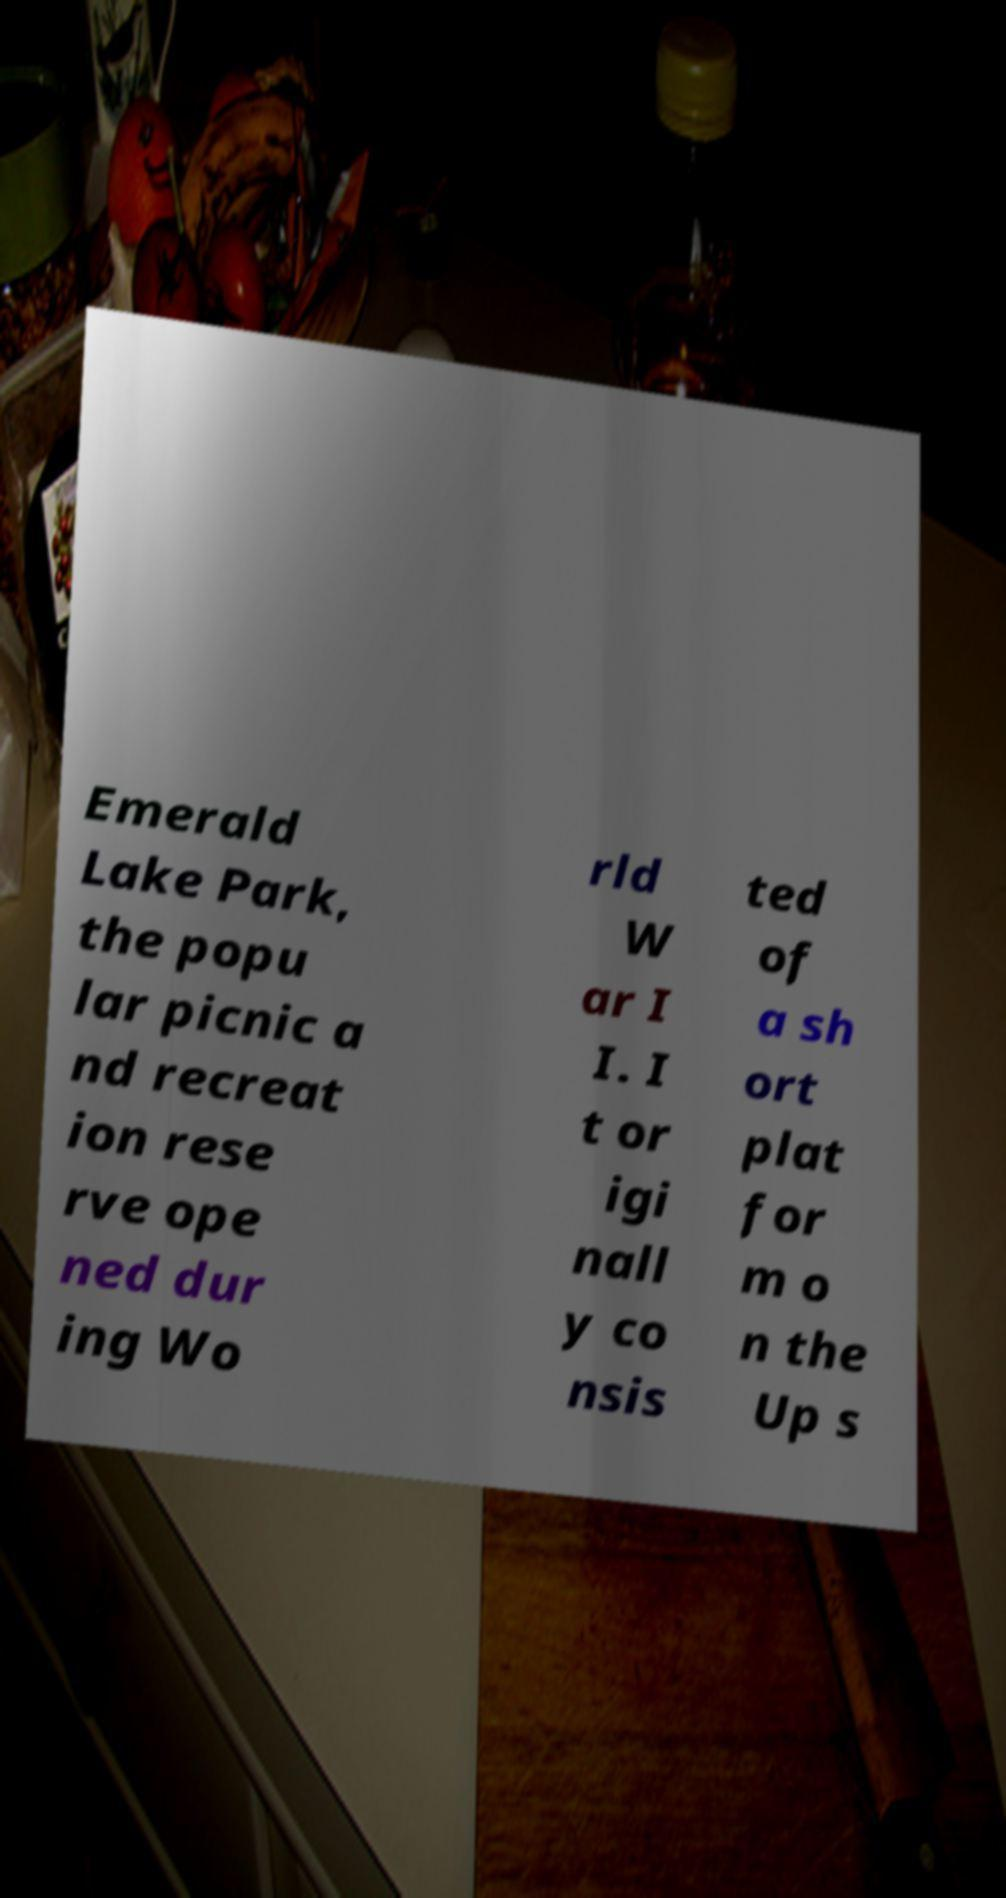For documentation purposes, I need the text within this image transcribed. Could you provide that? Emerald Lake Park, the popu lar picnic a nd recreat ion rese rve ope ned dur ing Wo rld W ar I I. I t or igi nall y co nsis ted of a sh ort plat for m o n the Up s 